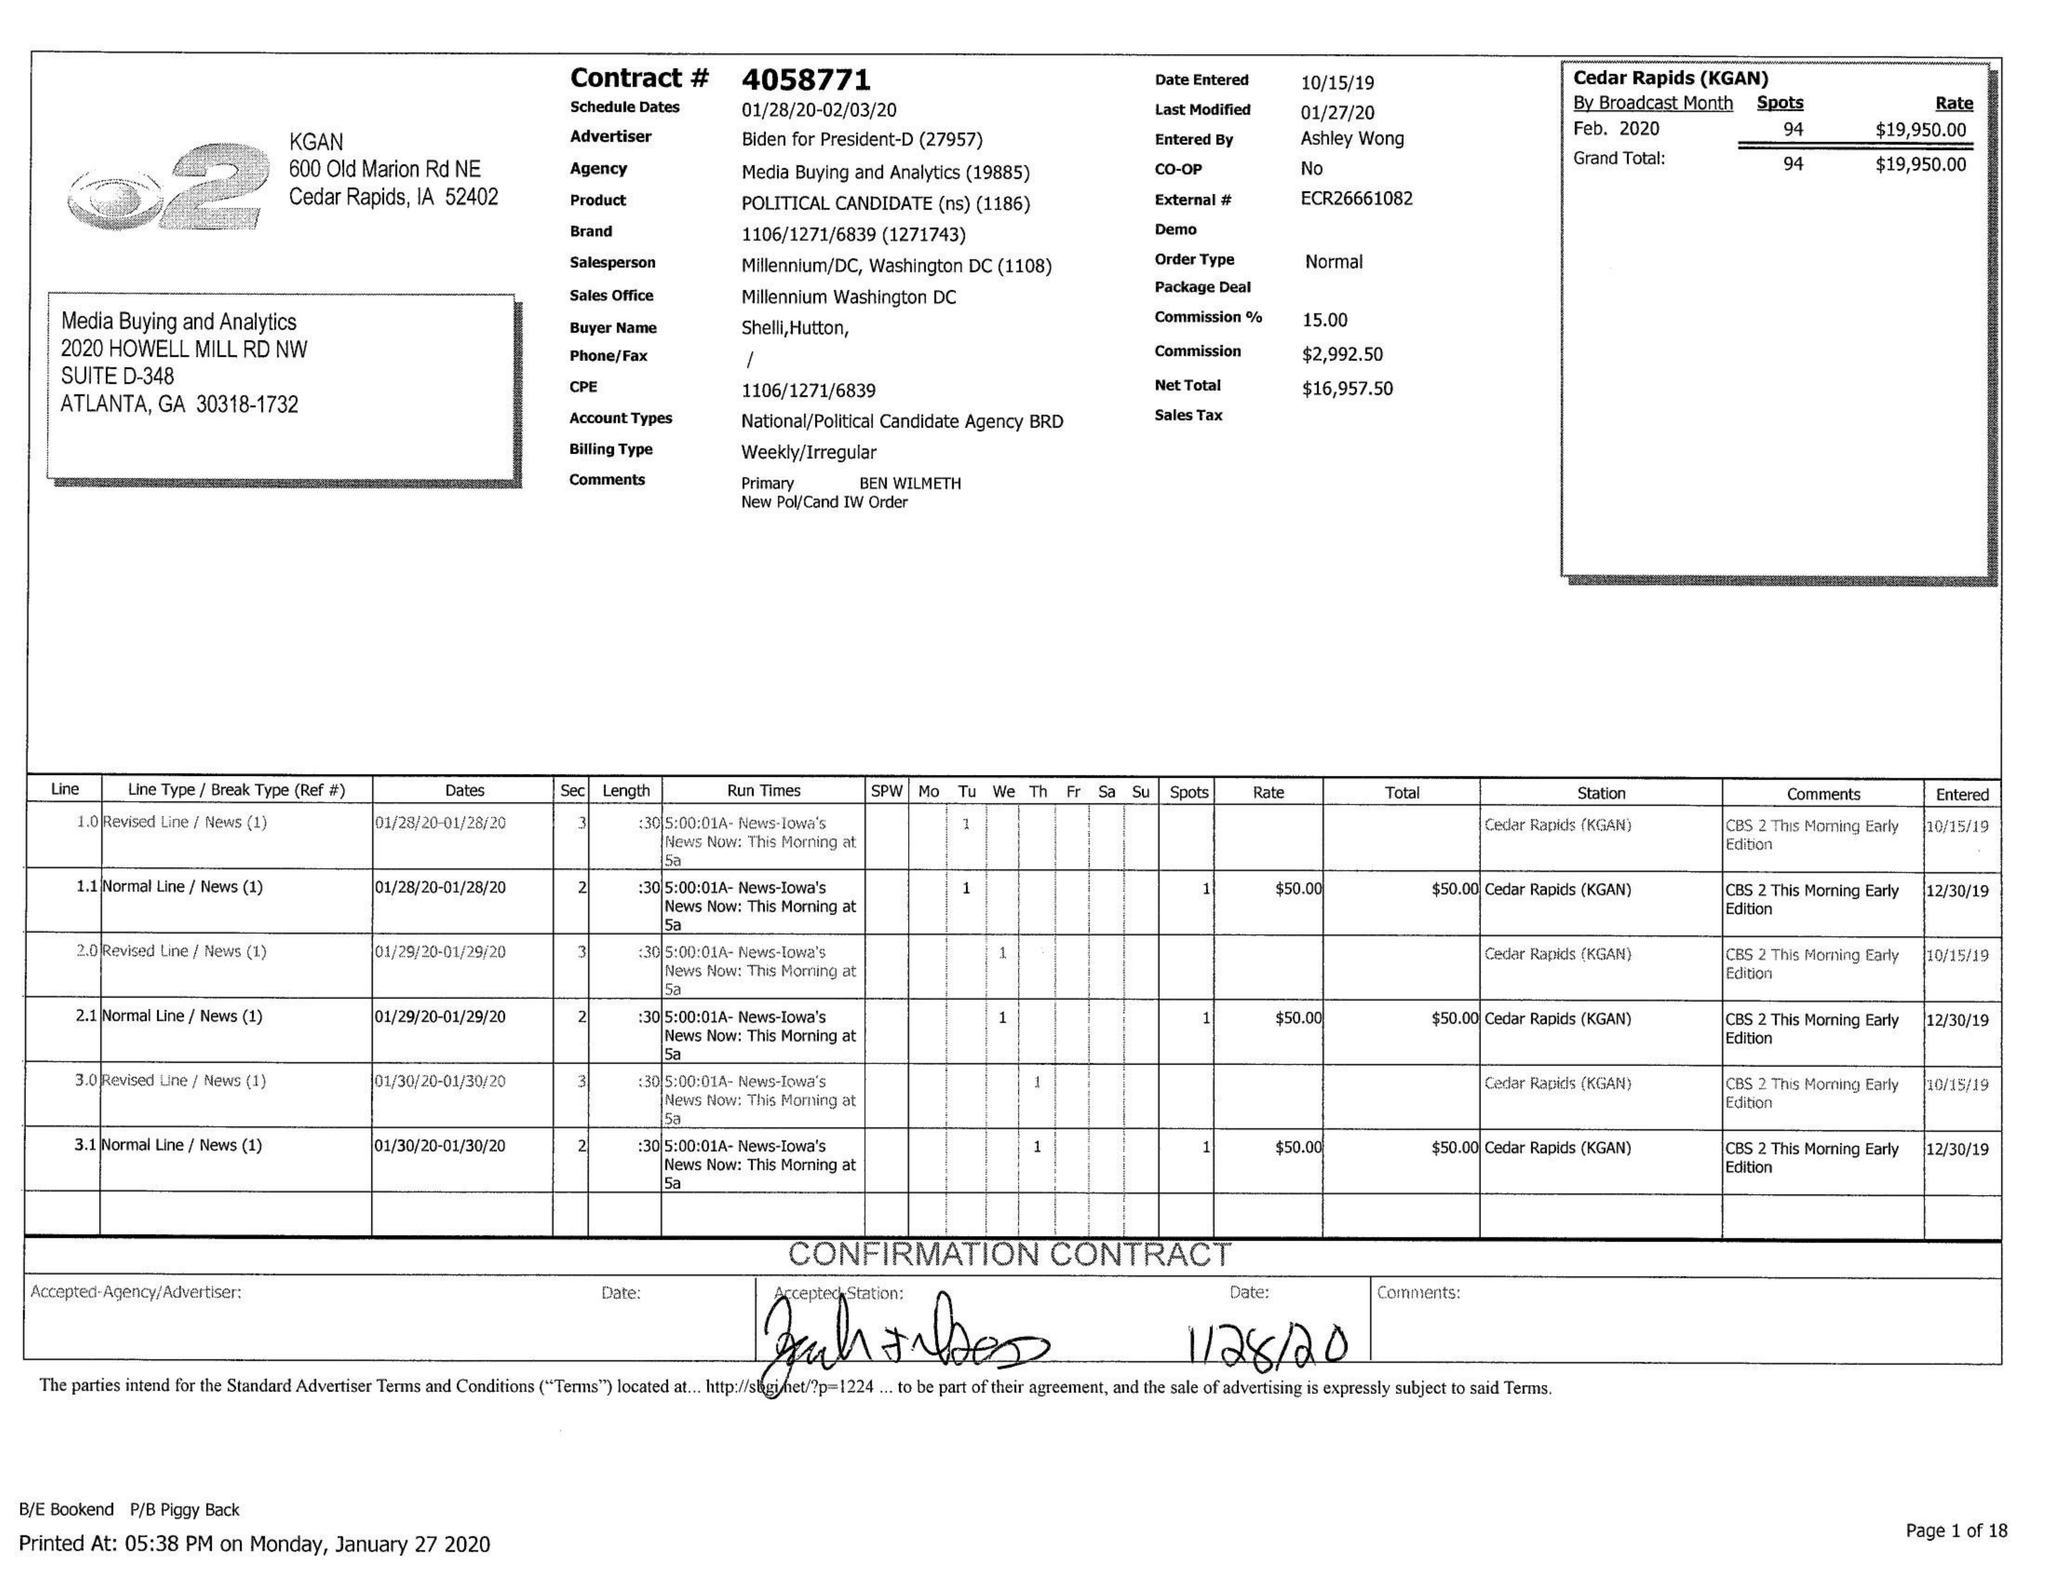What is the value for the flight_to?
Answer the question using a single word or phrase. 02/03/20 